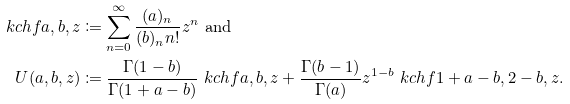<formula> <loc_0><loc_0><loc_500><loc_500>\ k c h f { a , b , z } & \coloneqq \sum _ { n = 0 } ^ { \infty } \frac { ( a ) _ { n } } { ( b ) _ { n } n ! } z ^ { n } \ \text {and} \\ U ( a , b , z ) & \coloneqq \frac { \Gamma ( 1 - b ) } { \Gamma ( 1 + a - b ) } \ k c h f { a , b , z } + \frac { \Gamma ( b - 1 ) } { \Gamma ( a ) } z ^ { 1 - b } \ k c h f { 1 + a - b , 2 - b , z } .</formula> 